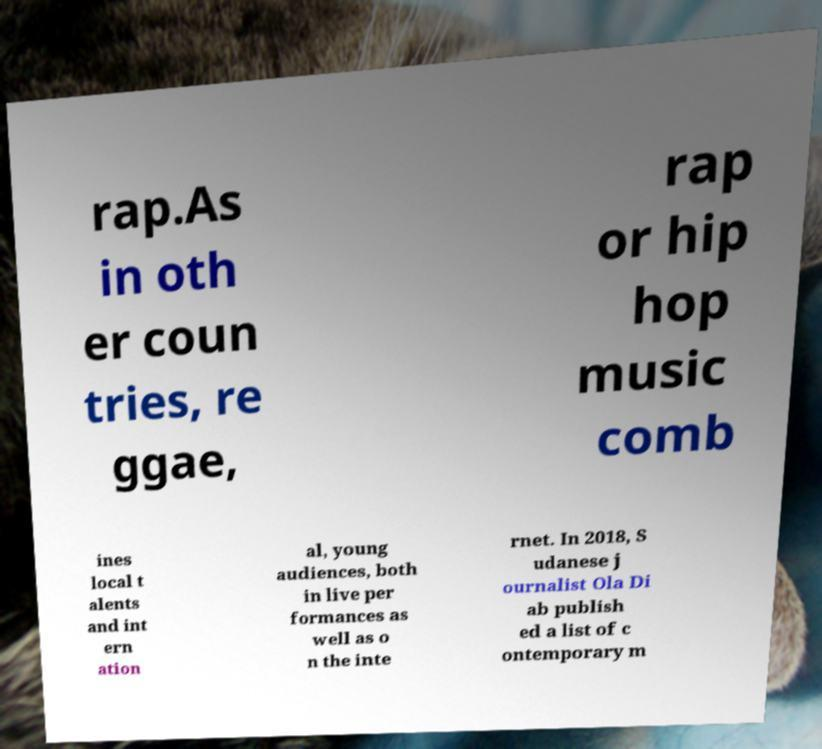For documentation purposes, I need the text within this image transcribed. Could you provide that? rap.As in oth er coun tries, re ggae, rap or hip hop music comb ines local t alents and int ern ation al, young audiences, both in live per formances as well as o n the inte rnet. In 2018, S udanese j ournalist Ola Di ab publish ed a list of c ontemporary m 